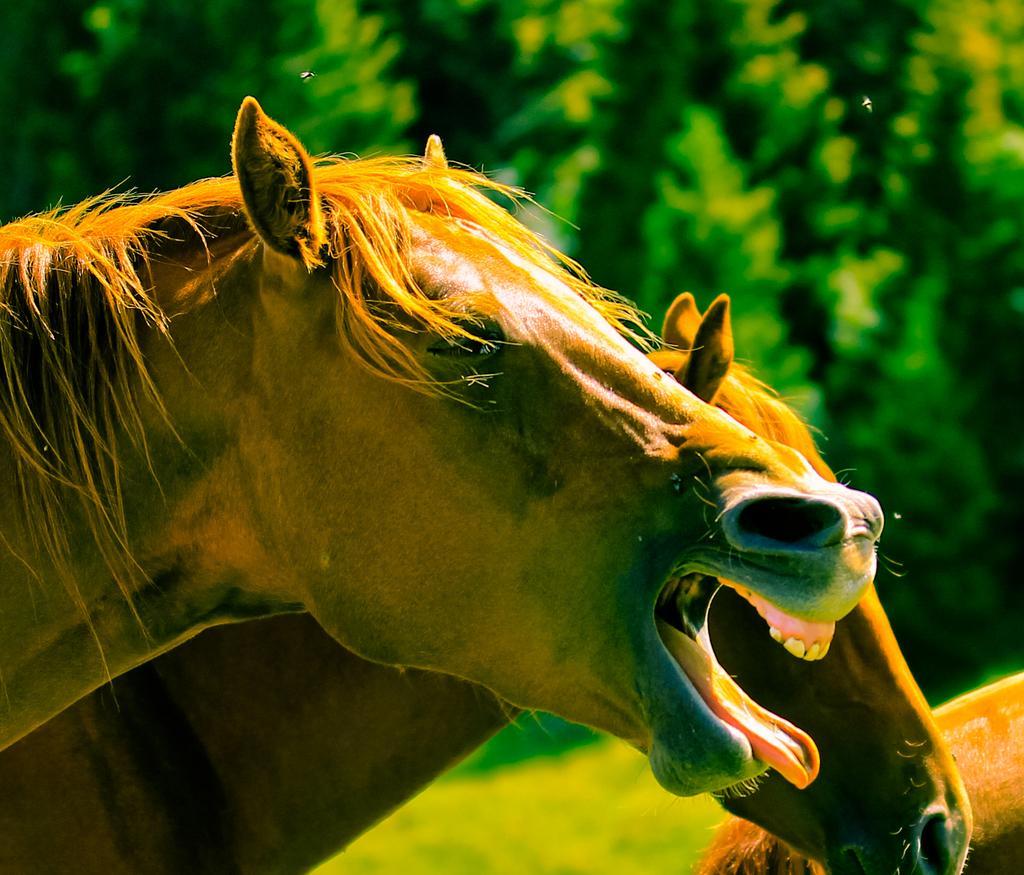In one or two sentences, can you explain what this image depicts? As we can see in the image there are horses, grass and trees. 